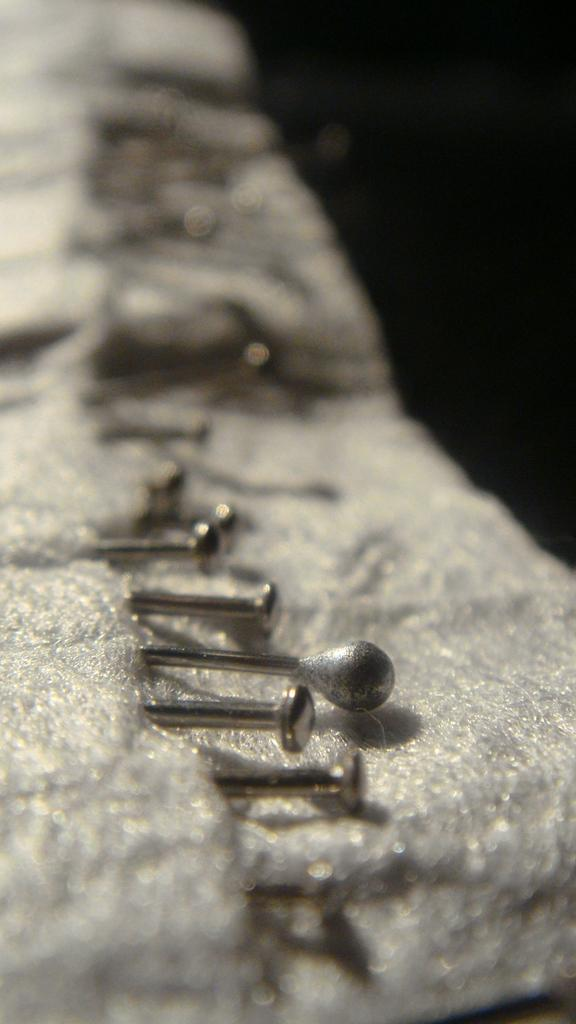What objects can be seen in the image? There are pins and cloth in the image. Can you describe the cloth in the image? The cloth is the main focus of the image, but its specific characteristics are not clear due to the blurred background. What is the background of the image like? The background of the image has a blurred view. How many lizards can be seen crawling on the jeans in the image? There are no jeans or lizards present in the image; it features pins and cloth with a blurred background. 